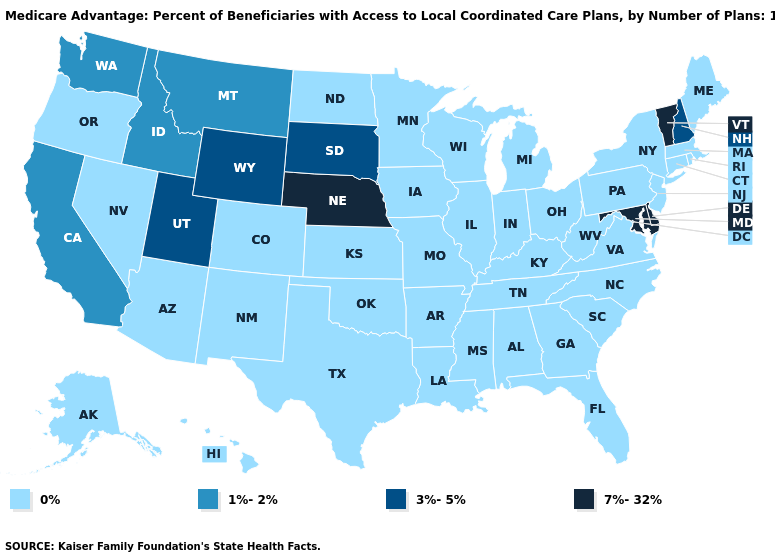Does North Dakota have the highest value in the MidWest?
Quick response, please. No. Among the states that border South Carolina , which have the highest value?
Give a very brief answer. Georgia, North Carolina. Name the states that have a value in the range 3%-5%?
Short answer required. New Hampshire, South Dakota, Utah, Wyoming. What is the highest value in the Northeast ?
Keep it brief. 7%-32%. What is the value of Arizona?
Short answer required. 0%. Among the states that border Connecticut , which have the highest value?
Keep it brief. Massachusetts, New York, Rhode Island. What is the value of South Dakota?
Answer briefly. 3%-5%. Name the states that have a value in the range 3%-5%?
Concise answer only. New Hampshire, South Dakota, Utah, Wyoming. What is the highest value in the USA?
Short answer required. 7%-32%. How many symbols are there in the legend?
Give a very brief answer. 4. What is the value of New Mexico?
Quick response, please. 0%. What is the highest value in the Northeast ?
Be succinct. 7%-32%. Does Florida have the lowest value in the USA?
Answer briefly. Yes. How many symbols are there in the legend?
Write a very short answer. 4. 